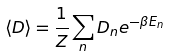<formula> <loc_0><loc_0><loc_500><loc_500>\langle D \rangle = \frac { 1 } { Z } \sum _ { n } D _ { n } e ^ { - \beta E _ { n } }</formula> 